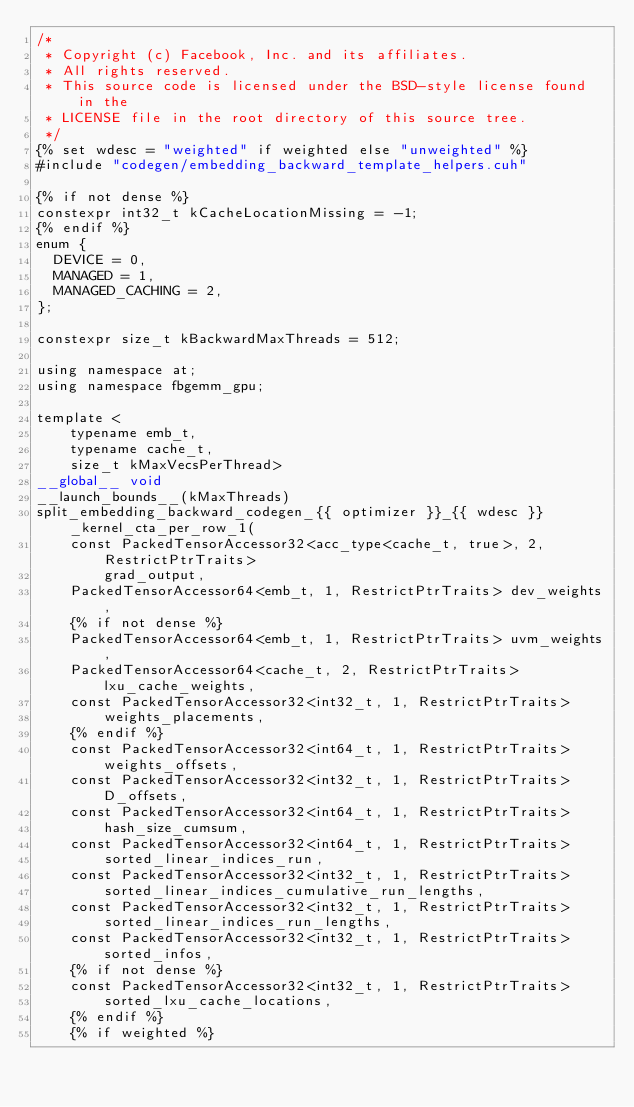<code> <loc_0><loc_0><loc_500><loc_500><_Cuda_>/*
 * Copyright (c) Facebook, Inc. and its affiliates.
 * All rights reserved.
 * This source code is licensed under the BSD-style license found in the
 * LICENSE file in the root directory of this source tree.
 */
{% set wdesc = "weighted" if weighted else "unweighted" %}
#include "codegen/embedding_backward_template_helpers.cuh"

{% if not dense %}
constexpr int32_t kCacheLocationMissing = -1;
{% endif %}
enum {
  DEVICE = 0,
  MANAGED = 1,
  MANAGED_CACHING = 2,
};

constexpr size_t kBackwardMaxThreads = 512;

using namespace at;
using namespace fbgemm_gpu;

template <
    typename emb_t,
    typename cache_t,
    size_t kMaxVecsPerThread>
__global__ void
__launch_bounds__(kMaxThreads)
split_embedding_backward_codegen_{{ optimizer }}_{{ wdesc }}_kernel_cta_per_row_1(
    const PackedTensorAccessor32<acc_type<cache_t, true>, 2, RestrictPtrTraits>
        grad_output,
    PackedTensorAccessor64<emb_t, 1, RestrictPtrTraits> dev_weights,
    {% if not dense %}
    PackedTensorAccessor64<emb_t, 1, RestrictPtrTraits> uvm_weights,
    PackedTensorAccessor64<cache_t, 2, RestrictPtrTraits> lxu_cache_weights,
    const PackedTensorAccessor32<int32_t, 1, RestrictPtrTraits>
        weights_placements,
    {% endif %}
    const PackedTensorAccessor32<int64_t, 1, RestrictPtrTraits> weights_offsets,
    const PackedTensorAccessor32<int32_t, 1, RestrictPtrTraits> D_offsets,
    const PackedTensorAccessor32<int64_t, 1, RestrictPtrTraits>
        hash_size_cumsum,
    const PackedTensorAccessor32<int64_t, 1, RestrictPtrTraits>
        sorted_linear_indices_run,
    const PackedTensorAccessor32<int32_t, 1, RestrictPtrTraits>
        sorted_linear_indices_cumulative_run_lengths,
    const PackedTensorAccessor32<int32_t, 1, RestrictPtrTraits>
        sorted_linear_indices_run_lengths,
    const PackedTensorAccessor32<int32_t, 1, RestrictPtrTraits> sorted_infos,
    {% if not dense %}
    const PackedTensorAccessor32<int32_t, 1, RestrictPtrTraits>
        sorted_lxu_cache_locations,
    {% endif %}
    {% if weighted %}</code> 